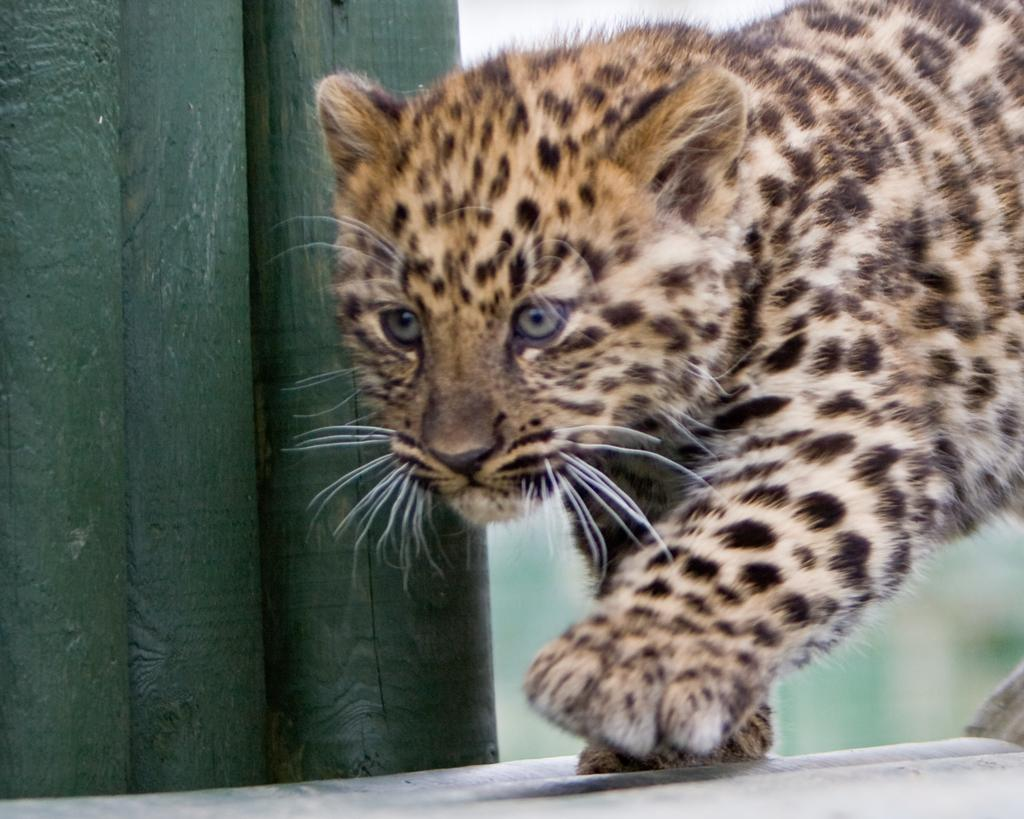What type of living creature is in the image? There is an animal in the image. What can be seen on the left side of the image? There is an object on the left side of the image. How would you describe the background of the image? The background of the image is blurred. What type of toothbrush is being used by the animal in the image? There is no toothbrush present in the image. Is there a fight happening between the animal and the object in the image? There is no fight depicted in the image; it only shows an animal and an object. 